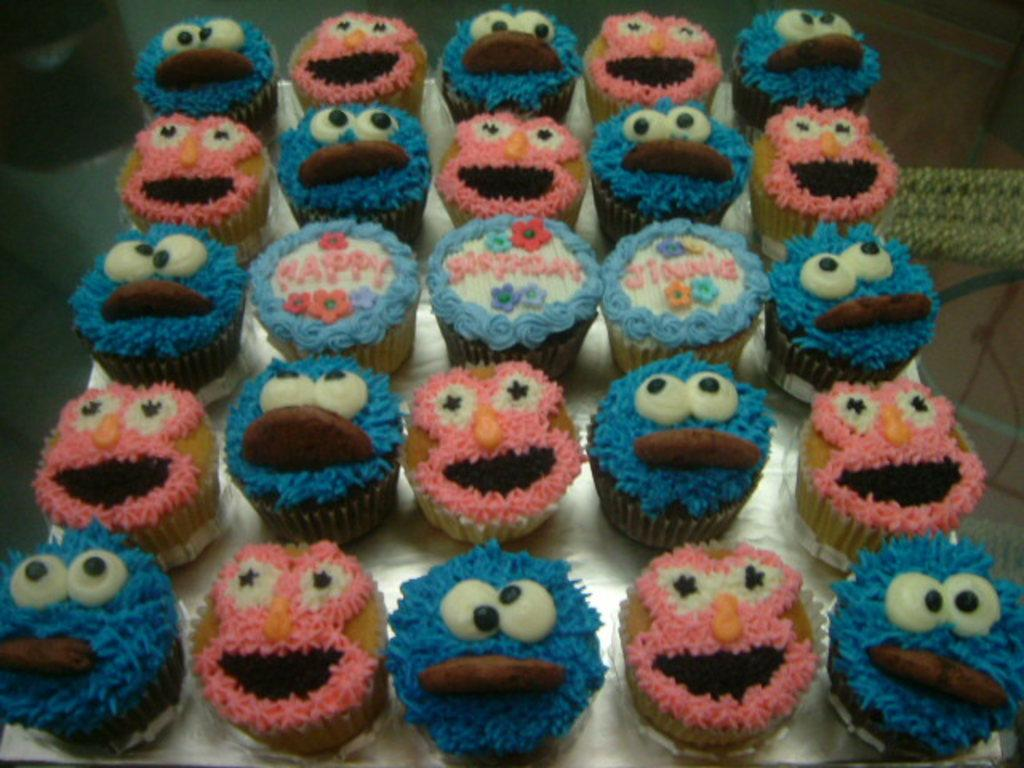What type of food can be seen in the image? There are cupcakes visible in the image. What is the object with cupcakes on it? There is an object with cupcakes on it, but the specific type of object is not mentioned in the facts. What can be seen on the right side of the image? There are objects on the right side of the image, but their specific nature is not mentioned in the facts. What can be seen on the left side of the image? There is an object on the left side of the image, but its specific nature is not mentioned in the facts. What type of roof can be seen on the hospital in the image? There is no roof or hospital present in the image; it features cupcakes and other objects. 